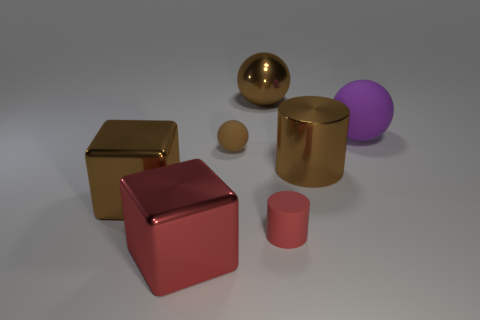How do the textures of the objects compare? The objects present a variety of textures. The gold and bronze items possess a shiny, reflective surface suggesting metal, while the matte appearance of the purple and brown objects implies a more rubber-like material. 